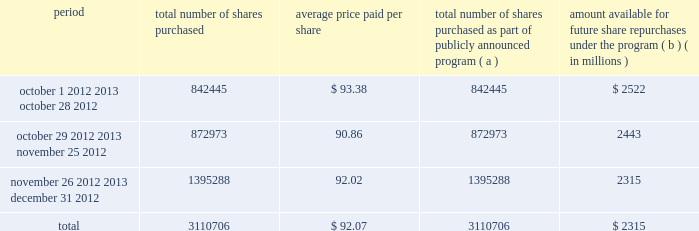Issuer purchases of equity securities the table provides information about our repurchases of common stock during the three-month period ended december 31 , 2012 .
Period total number of shares purchased average price paid per total number of shares purchased as part of publicly announced program ( a ) amount available for future share repurchases the program ( b ) ( in millions ) .
( a ) we repurchased a total of 3.1 million shares of our common stock for $ 286 million during the quarter ended december 31 , 2012 under a share repurchase program that we announced in october 2010 .
( b ) our board of directors has approved a share repurchase program for the repurchase of our common stock from time-to-time , authorizing an amount available for share repurchases of $ 6.5 billion .
Under the program , management has discretion to determine the dollar amount of shares to be repurchased and the timing of any repurchases in compliance with applicable law and regulation .
The program does not have an expiration date .
As of december 31 , 2012 , we had repurchased a total of 54.3 million shares under the program for $ 4.2 billion. .
What was the percent of the repurchases of common stock during the three-month ended december 312012 that was bought in october? 
Computations: (842445 / 3110706)
Answer: 0.27082. 